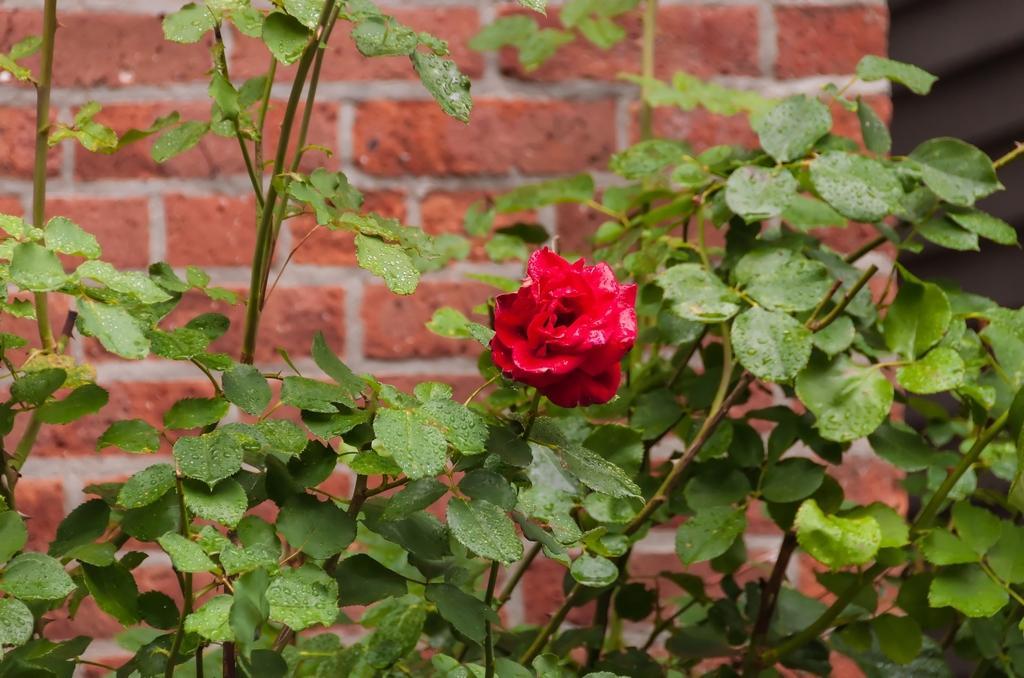Could you give a brief overview of what you see in this image? In this image I can see few plants and in the centre of this image I can see a red colour flower. I can also see the wall in the background. 